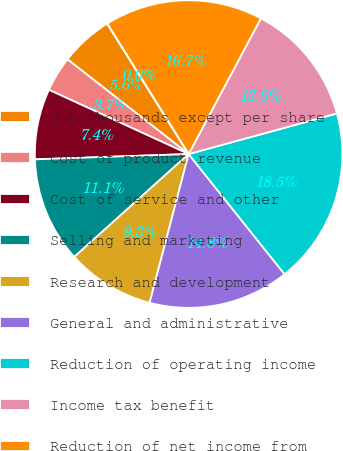Convert chart. <chart><loc_0><loc_0><loc_500><loc_500><pie_chart><fcel>(In thousands except per share<fcel>Cost of product revenue<fcel>Cost of service and other<fcel>Selling and marketing<fcel>Research and development<fcel>General and administrative<fcel>Reduction of operating income<fcel>Income tax benefit<fcel>Reduction of net income from<fcel>Basic<nl><fcel>5.56%<fcel>3.7%<fcel>7.41%<fcel>11.11%<fcel>9.26%<fcel>14.81%<fcel>18.52%<fcel>12.96%<fcel>16.67%<fcel>0.0%<nl></chart> 